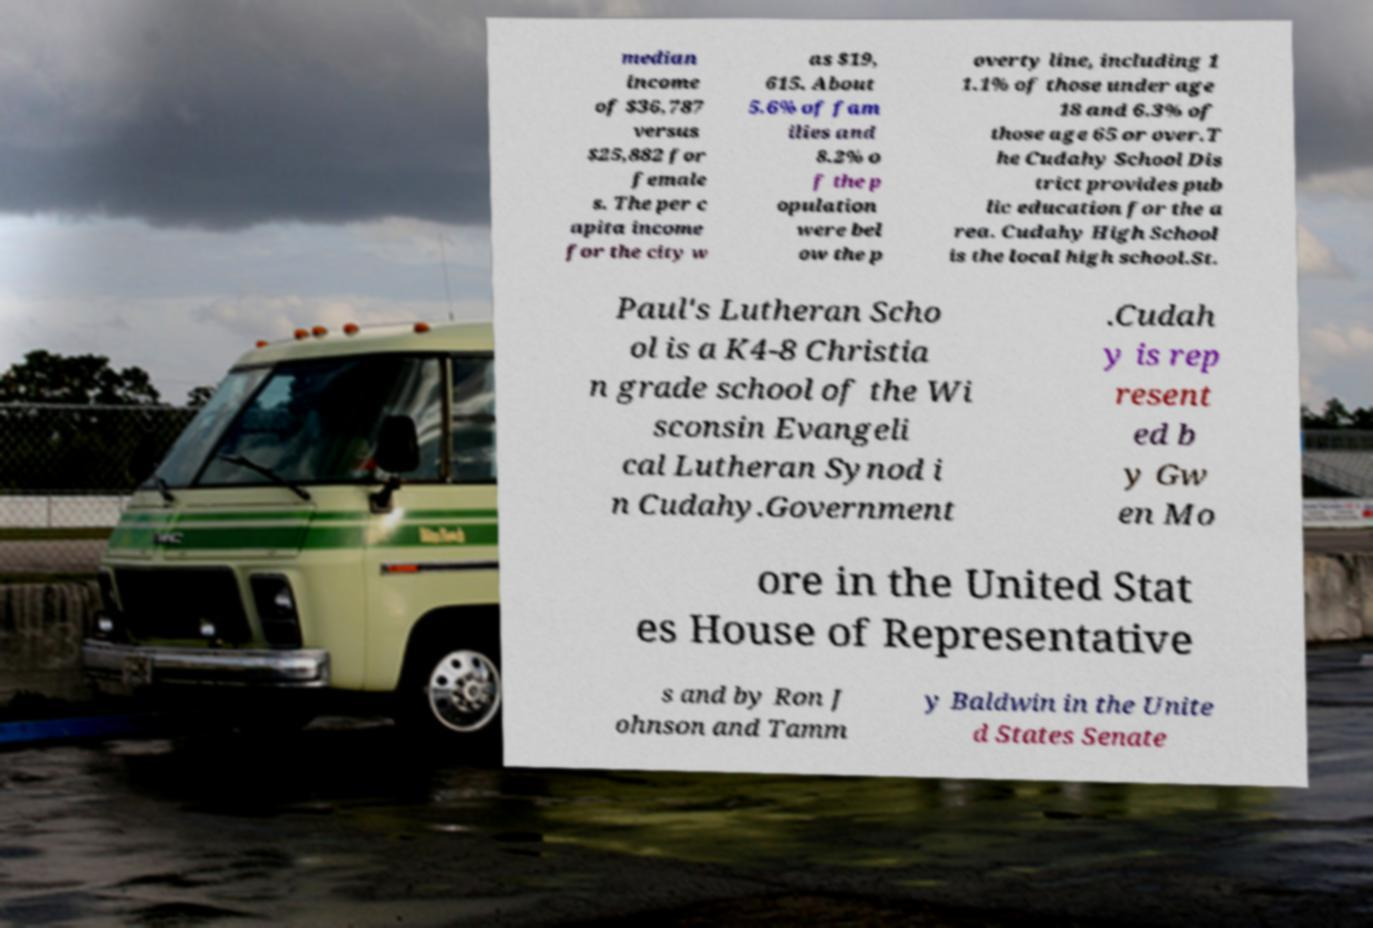What messages or text are displayed in this image? I need them in a readable, typed format. median income of $36,787 versus $25,882 for female s. The per c apita income for the city w as $19, 615. About 5.6% of fam ilies and 8.2% o f the p opulation were bel ow the p overty line, including 1 1.1% of those under age 18 and 6.3% of those age 65 or over.T he Cudahy School Dis trict provides pub lic education for the a rea. Cudahy High School is the local high school.St. Paul's Lutheran Scho ol is a K4-8 Christia n grade school of the Wi sconsin Evangeli cal Lutheran Synod i n Cudahy.Government .Cudah y is rep resent ed b y Gw en Mo ore in the United Stat es House of Representative s and by Ron J ohnson and Tamm y Baldwin in the Unite d States Senate 